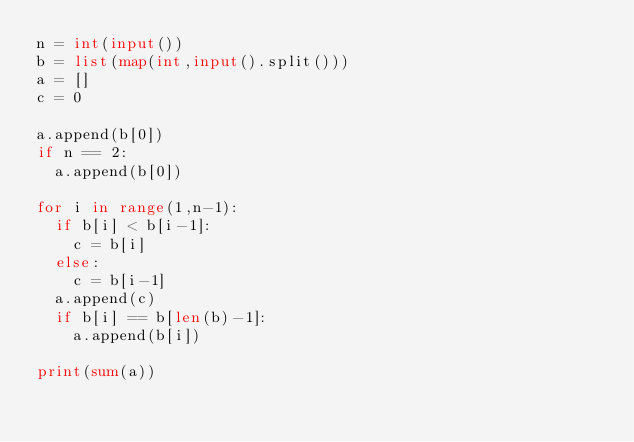Convert code to text. <code><loc_0><loc_0><loc_500><loc_500><_Python_>n = int(input())
b = list(map(int,input().split()))
a = []
c = 0
  
a.append(b[0])
if n == 2:
  a.append(b[0])
  
for i in range(1,n-1):
  if b[i] < b[i-1]:
    c = b[i]
  else:
    c = b[i-1]
  a.append(c)
  if b[i] == b[len(b)-1]:
    a.append(b[i])
  
print(sum(a))  </code> 